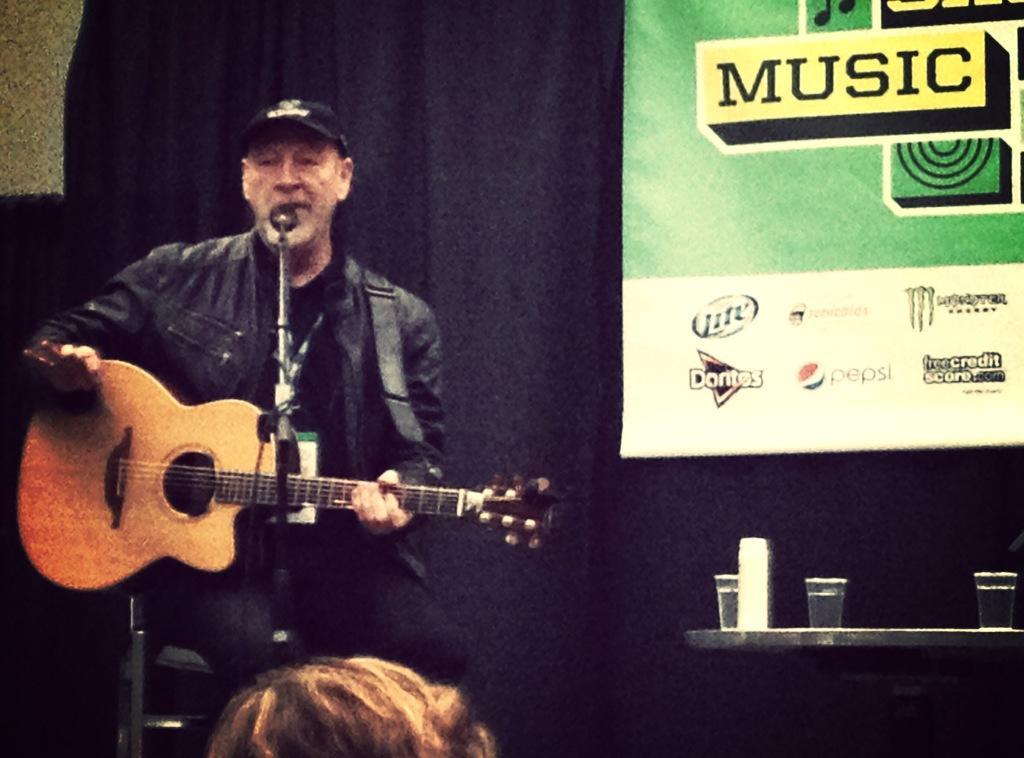Please provide a concise description of this image. In this image I can see a man who is holding a guitar and playing in front of a microphone. On the right side we have a couple of glasses on a table. 